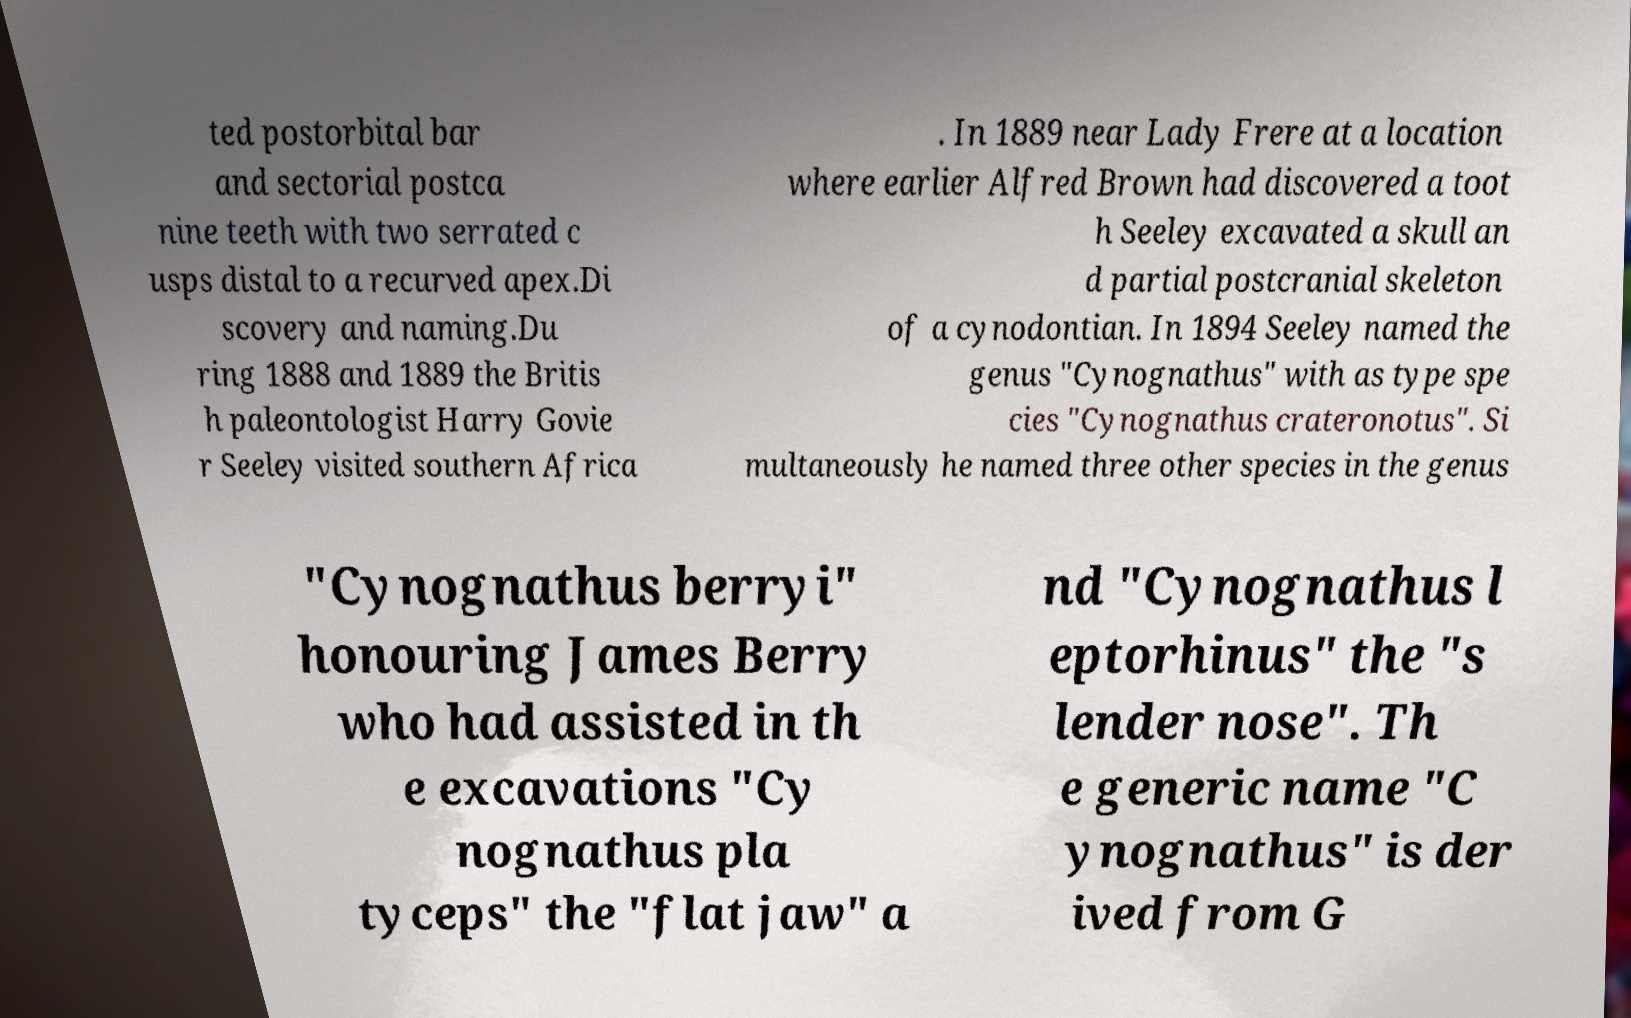There's text embedded in this image that I need extracted. Can you transcribe it verbatim? ted postorbital bar and sectorial postca nine teeth with two serrated c usps distal to a recurved apex.Di scovery and naming.Du ring 1888 and 1889 the Britis h paleontologist Harry Govie r Seeley visited southern Africa . In 1889 near Lady Frere at a location where earlier Alfred Brown had discovered a toot h Seeley excavated a skull an d partial postcranial skeleton of a cynodontian. In 1894 Seeley named the genus "Cynognathus" with as type spe cies "Cynognathus crateronotus". Si multaneously he named three other species in the genus "Cynognathus berryi" honouring James Berry who had assisted in th e excavations "Cy nognathus pla tyceps" the "flat jaw" a nd "Cynognathus l eptorhinus" the "s lender nose". Th e generic name "C ynognathus" is der ived from G 